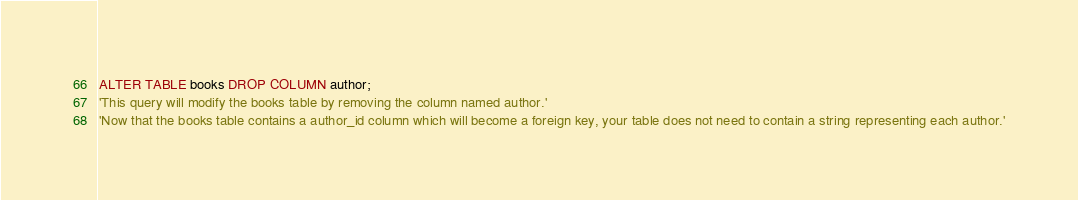Convert code to text. <code><loc_0><loc_0><loc_500><loc_500><_SQL_>ALTER TABLE books DROP COLUMN author;
'This query will modify the books table by removing the column named author.'
'Now that the books table contains a author_id column which will become a foreign key, your table does not need to contain a string representing each author.'</code> 